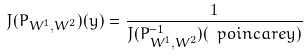Convert formula to latex. <formula><loc_0><loc_0><loc_500><loc_500>J ( P _ { W ^ { 1 } , W ^ { 2 } } ) ( y ) = \frac { 1 } { J ( P _ { W ^ { 1 } , W ^ { 2 } } ^ { - 1 } ) ( \ p o i n c a r e { y } ) }</formula> 